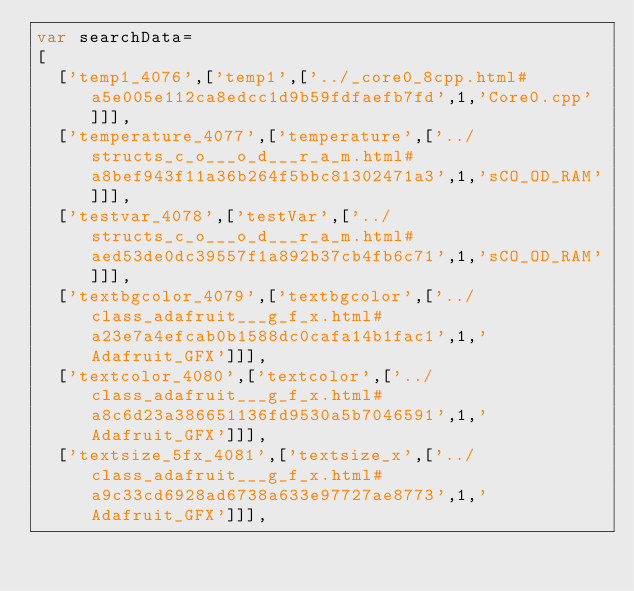<code> <loc_0><loc_0><loc_500><loc_500><_JavaScript_>var searchData=
[
  ['temp1_4076',['temp1',['../_core0_8cpp.html#a5e005e112ca8edcc1d9b59fdfaefb7fd',1,'Core0.cpp']]],
  ['temperature_4077',['temperature',['../structs_c_o___o_d___r_a_m.html#a8bef943f11a36b264f5bbc81302471a3',1,'sCO_OD_RAM']]],
  ['testvar_4078',['testVar',['../structs_c_o___o_d___r_a_m.html#aed53de0dc39557f1a892b37cb4fb6c71',1,'sCO_OD_RAM']]],
  ['textbgcolor_4079',['textbgcolor',['../class_adafruit___g_f_x.html#a23e7a4efcab0b1588dc0cafa14b1fac1',1,'Adafruit_GFX']]],
  ['textcolor_4080',['textcolor',['../class_adafruit___g_f_x.html#a8c6d23a386651136fd9530a5b7046591',1,'Adafruit_GFX']]],
  ['textsize_5fx_4081',['textsize_x',['../class_adafruit___g_f_x.html#a9c33cd6928ad6738a633e97727ae8773',1,'Adafruit_GFX']]],</code> 